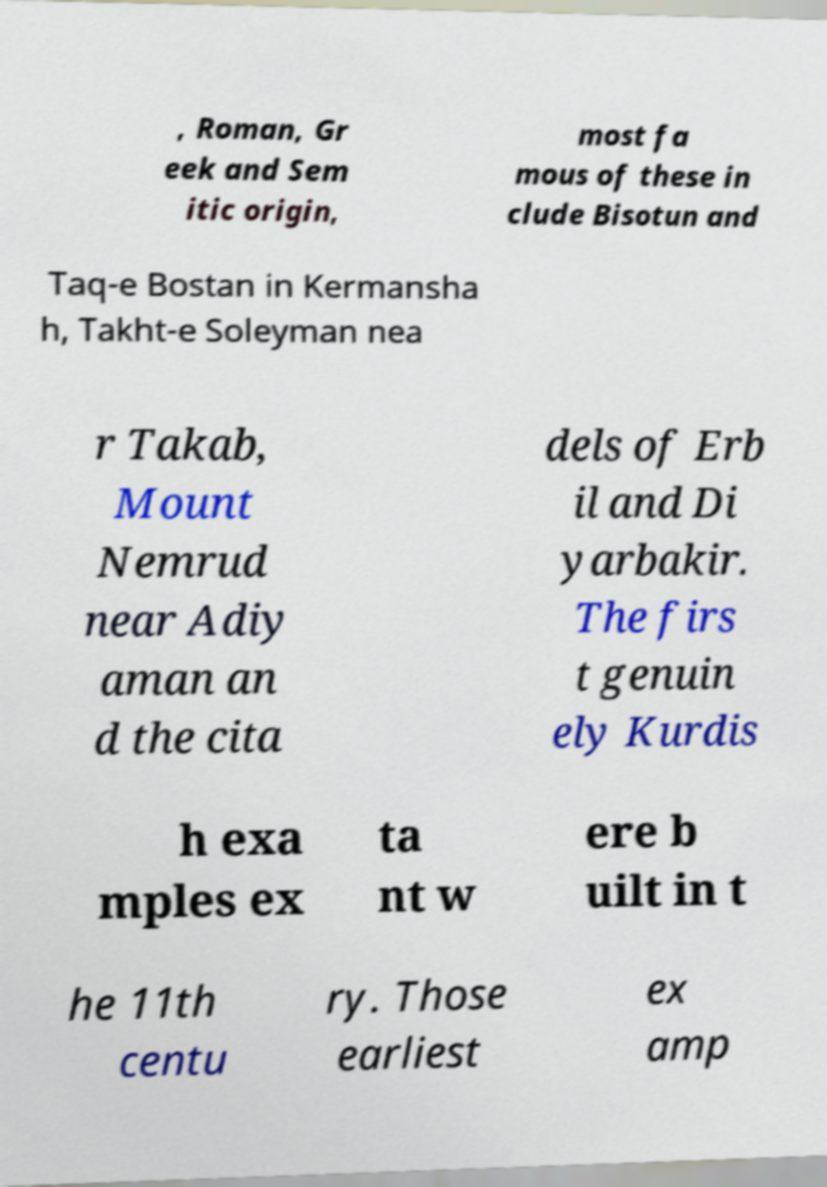Could you extract and type out the text from this image? , Roman, Gr eek and Sem itic origin, most fa mous of these in clude Bisotun and Taq-e Bostan in Kermansha h, Takht-e Soleyman nea r Takab, Mount Nemrud near Adiy aman an d the cita dels of Erb il and Di yarbakir. The firs t genuin ely Kurdis h exa mples ex ta nt w ere b uilt in t he 11th centu ry. Those earliest ex amp 